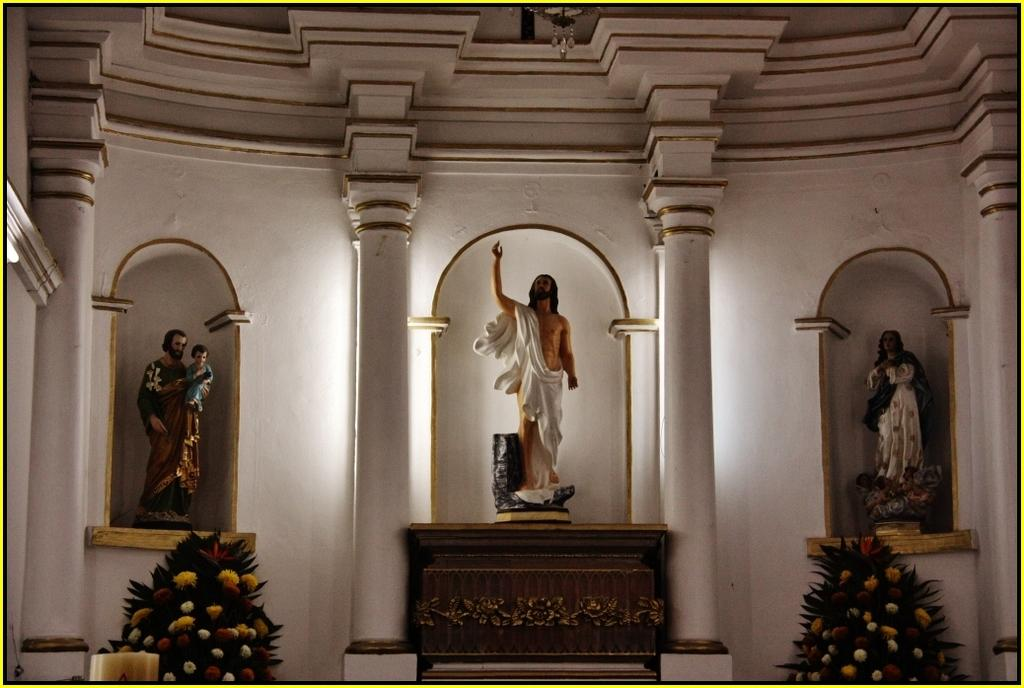What is located in the front of the image? There are plants in the front of the image. What can be seen in the center of the image? There are pillars in the center of the image. What is visible in the background of the image? There are statues and a wall in the background of the image. What is the color of the wall in the image? The wall is white in color. What type of yoke is being used by the person in the image? There is no person or yoke present in the image. How does the skirt on the statue in the image look? There are no skirts or statues wearing skirts in the image. 